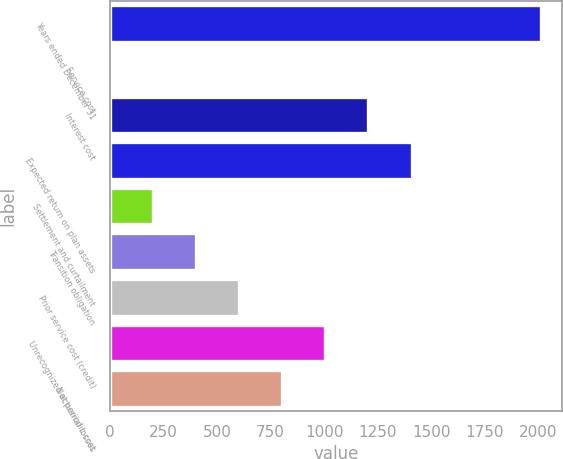<chart> <loc_0><loc_0><loc_500><loc_500><bar_chart><fcel>Years ended December 31<fcel>Service cost<fcel>Interest cost<fcel>Expected return on plan assets<fcel>Settlement and curtailment<fcel>Transition obligation<fcel>Prior service cost (credit)<fcel>Unrecognized actuarial losses<fcel>Net periodic cost<nl><fcel>2011<fcel>0.22<fcel>1206.7<fcel>1407.78<fcel>201.3<fcel>402.38<fcel>603.46<fcel>1005.62<fcel>804.54<nl></chart> 